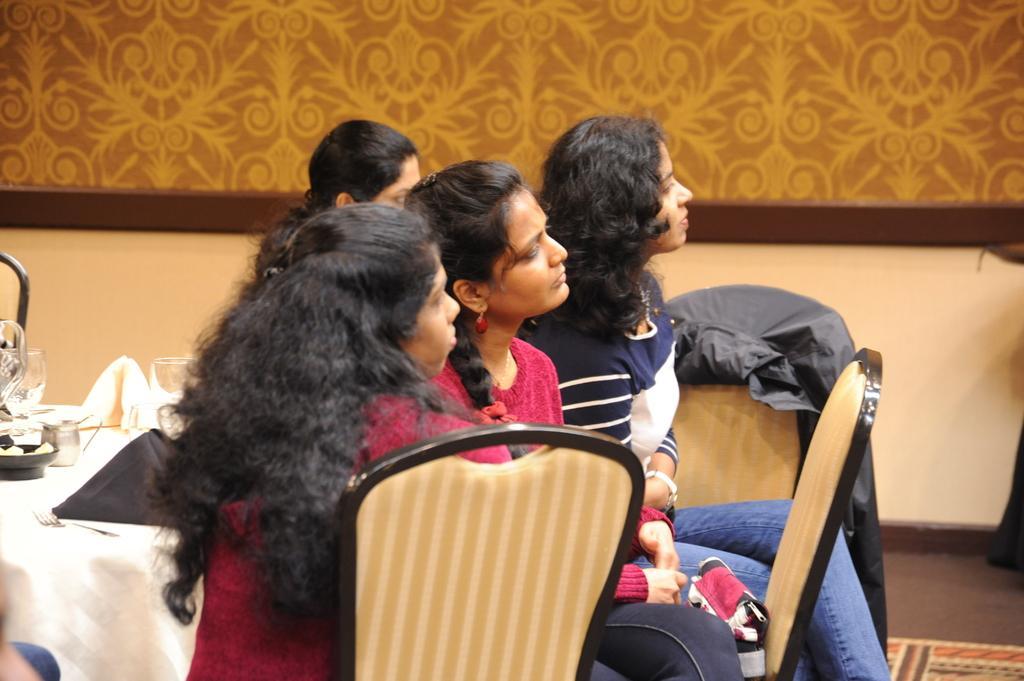How would you summarize this image in a sentence or two? In the center of the image we can see some persons are sitting on the chair. On the left side of the image there is a table. On the table we can see cloth, for, glass, vessels are there. In the background of the image wall is there. At the bottom right corner floor is present. 